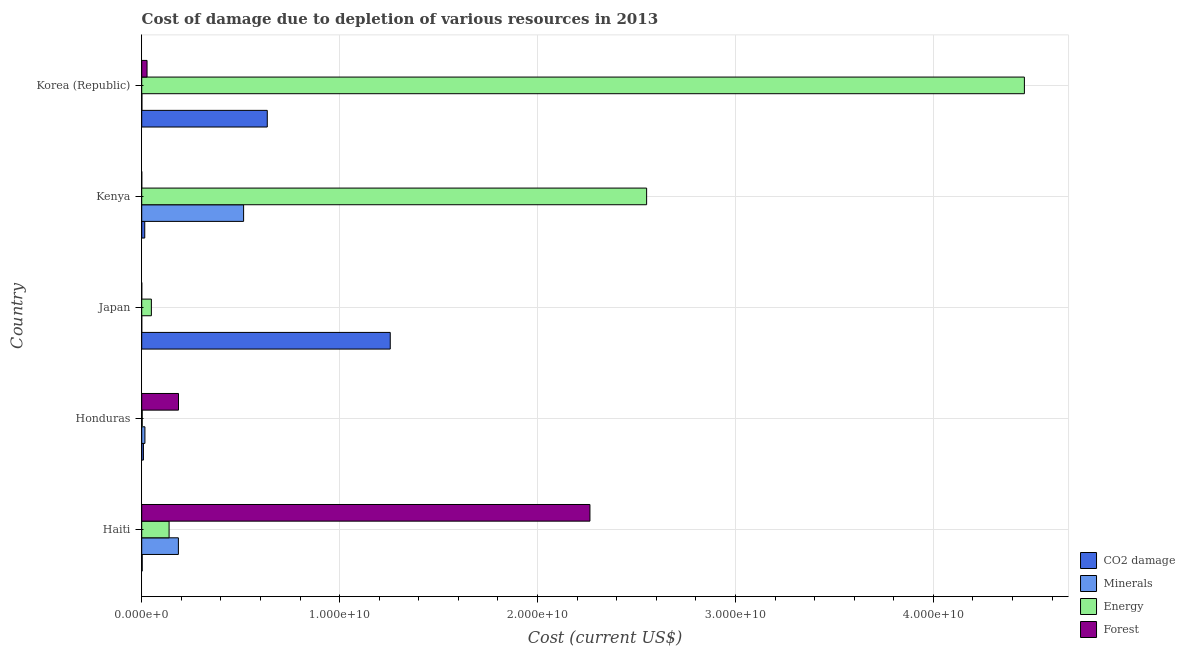How many different coloured bars are there?
Keep it short and to the point. 4. How many bars are there on the 5th tick from the bottom?
Give a very brief answer. 4. What is the cost of damage due to depletion of minerals in Honduras?
Offer a terse response. 1.62e+08. Across all countries, what is the maximum cost of damage due to depletion of forests?
Keep it short and to the point. 2.26e+1. Across all countries, what is the minimum cost of damage due to depletion of coal?
Your answer should be compact. 2.43e+07. In which country was the cost of damage due to depletion of forests maximum?
Your answer should be compact. Haiti. In which country was the cost of damage due to depletion of energy minimum?
Offer a very short reply. Honduras. What is the total cost of damage due to depletion of coal in the graph?
Offer a terse response. 1.92e+1. What is the difference between the cost of damage due to depletion of forests in Japan and that in Kenya?
Provide a succinct answer. -1.29e+06. What is the difference between the cost of damage due to depletion of minerals in Japan and the cost of damage due to depletion of coal in Honduras?
Keep it short and to the point. -8.53e+07. What is the average cost of damage due to depletion of coal per country?
Give a very brief answer. 3.83e+09. What is the difference between the cost of damage due to depletion of coal and cost of damage due to depletion of minerals in Haiti?
Your response must be concise. -1.83e+09. What is the ratio of the cost of damage due to depletion of energy in Kenya to that in Korea (Republic)?
Provide a short and direct response. 0.57. Is the difference between the cost of damage due to depletion of minerals in Kenya and Korea (Republic) greater than the difference between the cost of damage due to depletion of coal in Kenya and Korea (Republic)?
Ensure brevity in your answer.  Yes. What is the difference between the highest and the second highest cost of damage due to depletion of forests?
Make the answer very short. 2.08e+1. What is the difference between the highest and the lowest cost of damage due to depletion of minerals?
Give a very brief answer. 5.15e+09. Is it the case that in every country, the sum of the cost of damage due to depletion of minerals and cost of damage due to depletion of forests is greater than the sum of cost of damage due to depletion of energy and cost of damage due to depletion of coal?
Offer a terse response. No. What does the 2nd bar from the top in Haiti represents?
Your answer should be compact. Energy. What does the 2nd bar from the bottom in Haiti represents?
Your answer should be very brief. Minerals. How many bars are there?
Ensure brevity in your answer.  20. How many countries are there in the graph?
Your response must be concise. 5. What is the difference between two consecutive major ticks on the X-axis?
Offer a terse response. 1.00e+1. Does the graph contain grids?
Provide a succinct answer. Yes. How many legend labels are there?
Your response must be concise. 4. How are the legend labels stacked?
Offer a very short reply. Vertical. What is the title of the graph?
Offer a very short reply. Cost of damage due to depletion of various resources in 2013 . Does "Norway" appear as one of the legend labels in the graph?
Give a very brief answer. No. What is the label or title of the X-axis?
Give a very brief answer. Cost (current US$). What is the label or title of the Y-axis?
Your answer should be compact. Country. What is the Cost (current US$) in CO2 damage in Haiti?
Keep it short and to the point. 2.43e+07. What is the Cost (current US$) in Minerals in Haiti?
Offer a very short reply. 1.85e+09. What is the Cost (current US$) in Energy in Haiti?
Your response must be concise. 1.38e+09. What is the Cost (current US$) of Forest in Haiti?
Keep it short and to the point. 2.26e+1. What is the Cost (current US$) in CO2 damage in Honduras?
Keep it short and to the point. 8.56e+07. What is the Cost (current US$) in Minerals in Honduras?
Your answer should be very brief. 1.62e+08. What is the Cost (current US$) in Energy in Honduras?
Ensure brevity in your answer.  2.46e+07. What is the Cost (current US$) of Forest in Honduras?
Your response must be concise. 1.86e+09. What is the Cost (current US$) of CO2 damage in Japan?
Your response must be concise. 1.26e+1. What is the Cost (current US$) of Minerals in Japan?
Your answer should be compact. 3.10e+05. What is the Cost (current US$) of Energy in Japan?
Ensure brevity in your answer.  4.87e+08. What is the Cost (current US$) of Forest in Japan?
Your response must be concise. 2.51e+05. What is the Cost (current US$) in CO2 damage in Kenya?
Keep it short and to the point. 1.53e+08. What is the Cost (current US$) in Minerals in Kenya?
Offer a very short reply. 5.15e+09. What is the Cost (current US$) in Energy in Kenya?
Your response must be concise. 2.55e+1. What is the Cost (current US$) of Forest in Kenya?
Your answer should be compact. 1.54e+06. What is the Cost (current US$) in CO2 damage in Korea (Republic)?
Give a very brief answer. 6.34e+09. What is the Cost (current US$) of Minerals in Korea (Republic)?
Make the answer very short. 8.60e+06. What is the Cost (current US$) in Energy in Korea (Republic)?
Offer a terse response. 4.46e+1. What is the Cost (current US$) of Forest in Korea (Republic)?
Offer a terse response. 2.69e+08. Across all countries, what is the maximum Cost (current US$) of CO2 damage?
Offer a very short reply. 1.26e+1. Across all countries, what is the maximum Cost (current US$) of Minerals?
Your answer should be compact. 5.15e+09. Across all countries, what is the maximum Cost (current US$) in Energy?
Provide a short and direct response. 4.46e+1. Across all countries, what is the maximum Cost (current US$) of Forest?
Provide a short and direct response. 2.26e+1. Across all countries, what is the minimum Cost (current US$) of CO2 damage?
Your answer should be compact. 2.43e+07. Across all countries, what is the minimum Cost (current US$) of Minerals?
Ensure brevity in your answer.  3.10e+05. Across all countries, what is the minimum Cost (current US$) of Energy?
Your answer should be very brief. 2.46e+07. Across all countries, what is the minimum Cost (current US$) in Forest?
Provide a succinct answer. 2.51e+05. What is the total Cost (current US$) in CO2 damage in the graph?
Your response must be concise. 1.92e+1. What is the total Cost (current US$) of Minerals in the graph?
Provide a succinct answer. 7.17e+09. What is the total Cost (current US$) of Energy in the graph?
Your answer should be very brief. 7.20e+1. What is the total Cost (current US$) in Forest in the graph?
Provide a succinct answer. 2.48e+1. What is the difference between the Cost (current US$) of CO2 damage in Haiti and that in Honduras?
Your answer should be very brief. -6.14e+07. What is the difference between the Cost (current US$) of Minerals in Haiti and that in Honduras?
Offer a very short reply. 1.69e+09. What is the difference between the Cost (current US$) of Energy in Haiti and that in Honduras?
Your answer should be compact. 1.36e+09. What is the difference between the Cost (current US$) of Forest in Haiti and that in Honduras?
Your response must be concise. 2.08e+1. What is the difference between the Cost (current US$) of CO2 damage in Haiti and that in Japan?
Offer a terse response. -1.25e+1. What is the difference between the Cost (current US$) in Minerals in Haiti and that in Japan?
Your answer should be compact. 1.85e+09. What is the difference between the Cost (current US$) of Energy in Haiti and that in Japan?
Provide a succinct answer. 8.95e+08. What is the difference between the Cost (current US$) of Forest in Haiti and that in Japan?
Give a very brief answer. 2.26e+1. What is the difference between the Cost (current US$) of CO2 damage in Haiti and that in Kenya?
Ensure brevity in your answer.  -1.29e+08. What is the difference between the Cost (current US$) of Minerals in Haiti and that in Kenya?
Your response must be concise. -3.30e+09. What is the difference between the Cost (current US$) in Energy in Haiti and that in Kenya?
Offer a terse response. -2.41e+1. What is the difference between the Cost (current US$) of Forest in Haiti and that in Kenya?
Give a very brief answer. 2.26e+1. What is the difference between the Cost (current US$) in CO2 damage in Haiti and that in Korea (Republic)?
Offer a very short reply. -6.32e+09. What is the difference between the Cost (current US$) in Minerals in Haiti and that in Korea (Republic)?
Keep it short and to the point. 1.84e+09. What is the difference between the Cost (current US$) in Energy in Haiti and that in Korea (Republic)?
Keep it short and to the point. -4.32e+1. What is the difference between the Cost (current US$) in Forest in Haiti and that in Korea (Republic)?
Your answer should be very brief. 2.24e+1. What is the difference between the Cost (current US$) in CO2 damage in Honduras and that in Japan?
Keep it short and to the point. -1.25e+1. What is the difference between the Cost (current US$) in Minerals in Honduras and that in Japan?
Your answer should be compact. 1.62e+08. What is the difference between the Cost (current US$) in Energy in Honduras and that in Japan?
Make the answer very short. -4.63e+08. What is the difference between the Cost (current US$) in Forest in Honduras and that in Japan?
Your answer should be compact. 1.86e+09. What is the difference between the Cost (current US$) in CO2 damage in Honduras and that in Kenya?
Make the answer very short. -6.77e+07. What is the difference between the Cost (current US$) in Minerals in Honduras and that in Kenya?
Your response must be concise. -4.99e+09. What is the difference between the Cost (current US$) of Energy in Honduras and that in Kenya?
Your answer should be very brief. -2.55e+1. What is the difference between the Cost (current US$) in Forest in Honduras and that in Kenya?
Your answer should be compact. 1.86e+09. What is the difference between the Cost (current US$) in CO2 damage in Honduras and that in Korea (Republic)?
Make the answer very short. -6.26e+09. What is the difference between the Cost (current US$) of Minerals in Honduras and that in Korea (Republic)?
Offer a terse response. 1.53e+08. What is the difference between the Cost (current US$) in Energy in Honduras and that in Korea (Republic)?
Make the answer very short. -4.46e+1. What is the difference between the Cost (current US$) in Forest in Honduras and that in Korea (Republic)?
Give a very brief answer. 1.59e+09. What is the difference between the Cost (current US$) of CO2 damage in Japan and that in Kenya?
Your answer should be very brief. 1.24e+1. What is the difference between the Cost (current US$) in Minerals in Japan and that in Kenya?
Keep it short and to the point. -5.15e+09. What is the difference between the Cost (current US$) of Energy in Japan and that in Kenya?
Provide a succinct answer. -2.50e+1. What is the difference between the Cost (current US$) of Forest in Japan and that in Kenya?
Offer a very short reply. -1.29e+06. What is the difference between the Cost (current US$) of CO2 damage in Japan and that in Korea (Republic)?
Your response must be concise. 6.21e+09. What is the difference between the Cost (current US$) of Minerals in Japan and that in Korea (Republic)?
Ensure brevity in your answer.  -8.29e+06. What is the difference between the Cost (current US$) in Energy in Japan and that in Korea (Republic)?
Offer a very short reply. -4.41e+1. What is the difference between the Cost (current US$) in Forest in Japan and that in Korea (Republic)?
Provide a succinct answer. -2.69e+08. What is the difference between the Cost (current US$) in CO2 damage in Kenya and that in Korea (Republic)?
Offer a very short reply. -6.19e+09. What is the difference between the Cost (current US$) in Minerals in Kenya and that in Korea (Republic)?
Provide a succinct answer. 5.14e+09. What is the difference between the Cost (current US$) of Energy in Kenya and that in Korea (Republic)?
Offer a terse response. -1.91e+1. What is the difference between the Cost (current US$) of Forest in Kenya and that in Korea (Republic)?
Make the answer very short. -2.68e+08. What is the difference between the Cost (current US$) of CO2 damage in Haiti and the Cost (current US$) of Minerals in Honduras?
Offer a very short reply. -1.38e+08. What is the difference between the Cost (current US$) of CO2 damage in Haiti and the Cost (current US$) of Energy in Honduras?
Keep it short and to the point. -3.39e+05. What is the difference between the Cost (current US$) in CO2 damage in Haiti and the Cost (current US$) in Forest in Honduras?
Offer a terse response. -1.83e+09. What is the difference between the Cost (current US$) in Minerals in Haiti and the Cost (current US$) in Energy in Honduras?
Provide a short and direct response. 1.83e+09. What is the difference between the Cost (current US$) in Minerals in Haiti and the Cost (current US$) in Forest in Honduras?
Offer a terse response. -5.24e+06. What is the difference between the Cost (current US$) of Energy in Haiti and the Cost (current US$) of Forest in Honduras?
Your response must be concise. -4.76e+08. What is the difference between the Cost (current US$) in CO2 damage in Haiti and the Cost (current US$) in Minerals in Japan?
Provide a succinct answer. 2.39e+07. What is the difference between the Cost (current US$) in CO2 damage in Haiti and the Cost (current US$) in Energy in Japan?
Offer a terse response. -4.63e+08. What is the difference between the Cost (current US$) in CO2 damage in Haiti and the Cost (current US$) in Forest in Japan?
Your response must be concise. 2.40e+07. What is the difference between the Cost (current US$) in Minerals in Haiti and the Cost (current US$) in Energy in Japan?
Your answer should be compact. 1.37e+09. What is the difference between the Cost (current US$) in Minerals in Haiti and the Cost (current US$) in Forest in Japan?
Provide a succinct answer. 1.85e+09. What is the difference between the Cost (current US$) in Energy in Haiti and the Cost (current US$) in Forest in Japan?
Your response must be concise. 1.38e+09. What is the difference between the Cost (current US$) in CO2 damage in Haiti and the Cost (current US$) in Minerals in Kenya?
Your answer should be very brief. -5.12e+09. What is the difference between the Cost (current US$) in CO2 damage in Haiti and the Cost (current US$) in Energy in Kenya?
Offer a terse response. -2.55e+1. What is the difference between the Cost (current US$) of CO2 damage in Haiti and the Cost (current US$) of Forest in Kenya?
Your response must be concise. 2.27e+07. What is the difference between the Cost (current US$) in Minerals in Haiti and the Cost (current US$) in Energy in Kenya?
Your response must be concise. -2.37e+1. What is the difference between the Cost (current US$) of Minerals in Haiti and the Cost (current US$) of Forest in Kenya?
Ensure brevity in your answer.  1.85e+09. What is the difference between the Cost (current US$) of Energy in Haiti and the Cost (current US$) of Forest in Kenya?
Offer a very short reply. 1.38e+09. What is the difference between the Cost (current US$) of CO2 damage in Haiti and the Cost (current US$) of Minerals in Korea (Republic)?
Provide a short and direct response. 1.56e+07. What is the difference between the Cost (current US$) of CO2 damage in Haiti and the Cost (current US$) of Energy in Korea (Republic)?
Provide a succinct answer. -4.46e+1. What is the difference between the Cost (current US$) in CO2 damage in Haiti and the Cost (current US$) in Forest in Korea (Republic)?
Offer a very short reply. -2.45e+08. What is the difference between the Cost (current US$) in Minerals in Haiti and the Cost (current US$) in Energy in Korea (Republic)?
Ensure brevity in your answer.  -4.27e+1. What is the difference between the Cost (current US$) in Minerals in Haiti and the Cost (current US$) in Forest in Korea (Republic)?
Make the answer very short. 1.58e+09. What is the difference between the Cost (current US$) in Energy in Haiti and the Cost (current US$) in Forest in Korea (Republic)?
Offer a very short reply. 1.11e+09. What is the difference between the Cost (current US$) of CO2 damage in Honduras and the Cost (current US$) of Minerals in Japan?
Provide a succinct answer. 8.53e+07. What is the difference between the Cost (current US$) in CO2 damage in Honduras and the Cost (current US$) in Energy in Japan?
Ensure brevity in your answer.  -4.02e+08. What is the difference between the Cost (current US$) of CO2 damage in Honduras and the Cost (current US$) of Forest in Japan?
Your answer should be compact. 8.54e+07. What is the difference between the Cost (current US$) of Minerals in Honduras and the Cost (current US$) of Energy in Japan?
Your response must be concise. -3.26e+08. What is the difference between the Cost (current US$) of Minerals in Honduras and the Cost (current US$) of Forest in Japan?
Offer a very short reply. 1.62e+08. What is the difference between the Cost (current US$) in Energy in Honduras and the Cost (current US$) in Forest in Japan?
Your answer should be very brief. 2.43e+07. What is the difference between the Cost (current US$) of CO2 damage in Honduras and the Cost (current US$) of Minerals in Kenya?
Provide a short and direct response. -5.06e+09. What is the difference between the Cost (current US$) in CO2 damage in Honduras and the Cost (current US$) in Energy in Kenya?
Make the answer very short. -2.54e+1. What is the difference between the Cost (current US$) of CO2 damage in Honduras and the Cost (current US$) of Forest in Kenya?
Keep it short and to the point. 8.41e+07. What is the difference between the Cost (current US$) of Minerals in Honduras and the Cost (current US$) of Energy in Kenya?
Your answer should be compact. -2.53e+1. What is the difference between the Cost (current US$) in Minerals in Honduras and the Cost (current US$) in Forest in Kenya?
Your response must be concise. 1.60e+08. What is the difference between the Cost (current US$) in Energy in Honduras and the Cost (current US$) in Forest in Kenya?
Your answer should be compact. 2.30e+07. What is the difference between the Cost (current US$) of CO2 damage in Honduras and the Cost (current US$) of Minerals in Korea (Republic)?
Keep it short and to the point. 7.70e+07. What is the difference between the Cost (current US$) of CO2 damage in Honduras and the Cost (current US$) of Energy in Korea (Republic)?
Give a very brief answer. -4.45e+1. What is the difference between the Cost (current US$) of CO2 damage in Honduras and the Cost (current US$) of Forest in Korea (Republic)?
Your response must be concise. -1.84e+08. What is the difference between the Cost (current US$) in Minerals in Honduras and the Cost (current US$) in Energy in Korea (Republic)?
Your answer should be very brief. -4.44e+1. What is the difference between the Cost (current US$) in Minerals in Honduras and the Cost (current US$) in Forest in Korea (Republic)?
Provide a succinct answer. -1.07e+08. What is the difference between the Cost (current US$) in Energy in Honduras and the Cost (current US$) in Forest in Korea (Republic)?
Give a very brief answer. -2.45e+08. What is the difference between the Cost (current US$) of CO2 damage in Japan and the Cost (current US$) of Minerals in Kenya?
Your answer should be very brief. 7.41e+09. What is the difference between the Cost (current US$) of CO2 damage in Japan and the Cost (current US$) of Energy in Kenya?
Your answer should be very brief. -1.30e+1. What is the difference between the Cost (current US$) of CO2 damage in Japan and the Cost (current US$) of Forest in Kenya?
Give a very brief answer. 1.26e+1. What is the difference between the Cost (current US$) of Minerals in Japan and the Cost (current US$) of Energy in Kenya?
Provide a short and direct response. -2.55e+1. What is the difference between the Cost (current US$) in Minerals in Japan and the Cost (current US$) in Forest in Kenya?
Your answer should be very brief. -1.23e+06. What is the difference between the Cost (current US$) of Energy in Japan and the Cost (current US$) of Forest in Kenya?
Make the answer very short. 4.86e+08. What is the difference between the Cost (current US$) of CO2 damage in Japan and the Cost (current US$) of Minerals in Korea (Republic)?
Make the answer very short. 1.25e+1. What is the difference between the Cost (current US$) of CO2 damage in Japan and the Cost (current US$) of Energy in Korea (Republic)?
Your response must be concise. -3.20e+1. What is the difference between the Cost (current US$) in CO2 damage in Japan and the Cost (current US$) in Forest in Korea (Republic)?
Give a very brief answer. 1.23e+1. What is the difference between the Cost (current US$) of Minerals in Japan and the Cost (current US$) of Energy in Korea (Republic)?
Offer a very short reply. -4.46e+1. What is the difference between the Cost (current US$) of Minerals in Japan and the Cost (current US$) of Forest in Korea (Republic)?
Offer a terse response. -2.69e+08. What is the difference between the Cost (current US$) of Energy in Japan and the Cost (current US$) of Forest in Korea (Republic)?
Ensure brevity in your answer.  2.18e+08. What is the difference between the Cost (current US$) in CO2 damage in Kenya and the Cost (current US$) in Minerals in Korea (Republic)?
Offer a terse response. 1.45e+08. What is the difference between the Cost (current US$) in CO2 damage in Kenya and the Cost (current US$) in Energy in Korea (Republic)?
Offer a terse response. -4.44e+1. What is the difference between the Cost (current US$) in CO2 damage in Kenya and the Cost (current US$) in Forest in Korea (Republic)?
Provide a short and direct response. -1.16e+08. What is the difference between the Cost (current US$) of Minerals in Kenya and the Cost (current US$) of Energy in Korea (Republic)?
Offer a terse response. -3.94e+1. What is the difference between the Cost (current US$) in Minerals in Kenya and the Cost (current US$) in Forest in Korea (Republic)?
Your answer should be very brief. 4.88e+09. What is the difference between the Cost (current US$) in Energy in Kenya and the Cost (current US$) in Forest in Korea (Republic)?
Give a very brief answer. 2.52e+1. What is the average Cost (current US$) in CO2 damage per country?
Ensure brevity in your answer.  3.83e+09. What is the average Cost (current US$) of Minerals per country?
Keep it short and to the point. 1.43e+09. What is the average Cost (current US$) of Energy per country?
Provide a short and direct response. 1.44e+1. What is the average Cost (current US$) in Forest per country?
Provide a short and direct response. 4.96e+09. What is the difference between the Cost (current US$) of CO2 damage and Cost (current US$) of Minerals in Haiti?
Your answer should be compact. -1.83e+09. What is the difference between the Cost (current US$) of CO2 damage and Cost (current US$) of Energy in Haiti?
Provide a short and direct response. -1.36e+09. What is the difference between the Cost (current US$) of CO2 damage and Cost (current US$) of Forest in Haiti?
Provide a succinct answer. -2.26e+1. What is the difference between the Cost (current US$) of Minerals and Cost (current US$) of Energy in Haiti?
Keep it short and to the point. 4.70e+08. What is the difference between the Cost (current US$) of Minerals and Cost (current US$) of Forest in Haiti?
Make the answer very short. -2.08e+1. What is the difference between the Cost (current US$) in Energy and Cost (current US$) in Forest in Haiti?
Keep it short and to the point. -2.13e+1. What is the difference between the Cost (current US$) in CO2 damage and Cost (current US$) in Minerals in Honduras?
Your response must be concise. -7.63e+07. What is the difference between the Cost (current US$) of CO2 damage and Cost (current US$) of Energy in Honduras?
Keep it short and to the point. 6.10e+07. What is the difference between the Cost (current US$) of CO2 damage and Cost (current US$) of Forest in Honduras?
Give a very brief answer. -1.77e+09. What is the difference between the Cost (current US$) in Minerals and Cost (current US$) in Energy in Honduras?
Your answer should be very brief. 1.37e+08. What is the difference between the Cost (current US$) in Minerals and Cost (current US$) in Forest in Honduras?
Offer a terse response. -1.70e+09. What is the difference between the Cost (current US$) of Energy and Cost (current US$) of Forest in Honduras?
Your answer should be compact. -1.83e+09. What is the difference between the Cost (current US$) of CO2 damage and Cost (current US$) of Minerals in Japan?
Keep it short and to the point. 1.26e+1. What is the difference between the Cost (current US$) of CO2 damage and Cost (current US$) of Energy in Japan?
Offer a terse response. 1.21e+1. What is the difference between the Cost (current US$) in CO2 damage and Cost (current US$) in Forest in Japan?
Provide a succinct answer. 1.26e+1. What is the difference between the Cost (current US$) of Minerals and Cost (current US$) of Energy in Japan?
Ensure brevity in your answer.  -4.87e+08. What is the difference between the Cost (current US$) in Minerals and Cost (current US$) in Forest in Japan?
Keep it short and to the point. 5.93e+04. What is the difference between the Cost (current US$) of Energy and Cost (current US$) of Forest in Japan?
Give a very brief answer. 4.87e+08. What is the difference between the Cost (current US$) of CO2 damage and Cost (current US$) of Minerals in Kenya?
Provide a short and direct response. -5.00e+09. What is the difference between the Cost (current US$) in CO2 damage and Cost (current US$) in Energy in Kenya?
Keep it short and to the point. -2.54e+1. What is the difference between the Cost (current US$) of CO2 damage and Cost (current US$) of Forest in Kenya?
Your answer should be compact. 1.52e+08. What is the difference between the Cost (current US$) of Minerals and Cost (current US$) of Energy in Kenya?
Make the answer very short. -2.04e+1. What is the difference between the Cost (current US$) in Minerals and Cost (current US$) in Forest in Kenya?
Ensure brevity in your answer.  5.15e+09. What is the difference between the Cost (current US$) of Energy and Cost (current US$) of Forest in Kenya?
Offer a terse response. 2.55e+1. What is the difference between the Cost (current US$) in CO2 damage and Cost (current US$) in Minerals in Korea (Republic)?
Offer a terse response. 6.34e+09. What is the difference between the Cost (current US$) in CO2 damage and Cost (current US$) in Energy in Korea (Republic)?
Ensure brevity in your answer.  -3.83e+1. What is the difference between the Cost (current US$) in CO2 damage and Cost (current US$) in Forest in Korea (Republic)?
Provide a succinct answer. 6.07e+09. What is the difference between the Cost (current US$) of Minerals and Cost (current US$) of Energy in Korea (Republic)?
Ensure brevity in your answer.  -4.46e+1. What is the difference between the Cost (current US$) in Minerals and Cost (current US$) in Forest in Korea (Republic)?
Make the answer very short. -2.61e+08. What is the difference between the Cost (current US$) of Energy and Cost (current US$) of Forest in Korea (Republic)?
Ensure brevity in your answer.  4.43e+1. What is the ratio of the Cost (current US$) in CO2 damage in Haiti to that in Honduras?
Provide a short and direct response. 0.28. What is the ratio of the Cost (current US$) of Minerals in Haiti to that in Honduras?
Provide a short and direct response. 11.45. What is the ratio of the Cost (current US$) in Energy in Haiti to that in Honduras?
Your response must be concise. 56.23. What is the ratio of the Cost (current US$) of Forest in Haiti to that in Honduras?
Your answer should be compact. 12.19. What is the ratio of the Cost (current US$) in CO2 damage in Haiti to that in Japan?
Your answer should be compact. 0. What is the ratio of the Cost (current US$) in Minerals in Haiti to that in Japan?
Make the answer very short. 5978.24. What is the ratio of the Cost (current US$) of Energy in Haiti to that in Japan?
Make the answer very short. 2.84. What is the ratio of the Cost (current US$) of Forest in Haiti to that in Japan?
Your answer should be compact. 9.03e+04. What is the ratio of the Cost (current US$) in CO2 damage in Haiti to that in Kenya?
Make the answer very short. 0.16. What is the ratio of the Cost (current US$) of Minerals in Haiti to that in Kenya?
Your answer should be compact. 0.36. What is the ratio of the Cost (current US$) in Energy in Haiti to that in Kenya?
Your answer should be very brief. 0.05. What is the ratio of the Cost (current US$) in Forest in Haiti to that in Kenya?
Your answer should be very brief. 1.47e+04. What is the ratio of the Cost (current US$) in CO2 damage in Haiti to that in Korea (Republic)?
Provide a succinct answer. 0. What is the ratio of the Cost (current US$) in Minerals in Haiti to that in Korea (Republic)?
Your response must be concise. 215.42. What is the ratio of the Cost (current US$) of Energy in Haiti to that in Korea (Republic)?
Give a very brief answer. 0.03. What is the ratio of the Cost (current US$) of Forest in Haiti to that in Korea (Republic)?
Make the answer very short. 84.1. What is the ratio of the Cost (current US$) of CO2 damage in Honduras to that in Japan?
Offer a very short reply. 0.01. What is the ratio of the Cost (current US$) in Minerals in Honduras to that in Japan?
Offer a very short reply. 522.25. What is the ratio of the Cost (current US$) in Energy in Honduras to that in Japan?
Your response must be concise. 0.05. What is the ratio of the Cost (current US$) of Forest in Honduras to that in Japan?
Offer a terse response. 7413.82. What is the ratio of the Cost (current US$) in CO2 damage in Honduras to that in Kenya?
Provide a succinct answer. 0.56. What is the ratio of the Cost (current US$) in Minerals in Honduras to that in Kenya?
Provide a succinct answer. 0.03. What is the ratio of the Cost (current US$) of Forest in Honduras to that in Kenya?
Your answer should be very brief. 1204.94. What is the ratio of the Cost (current US$) in CO2 damage in Honduras to that in Korea (Republic)?
Give a very brief answer. 0.01. What is the ratio of the Cost (current US$) in Minerals in Honduras to that in Korea (Republic)?
Provide a succinct answer. 18.82. What is the ratio of the Cost (current US$) of Energy in Honduras to that in Korea (Republic)?
Provide a succinct answer. 0. What is the ratio of the Cost (current US$) of Forest in Honduras to that in Korea (Republic)?
Keep it short and to the point. 6.9. What is the ratio of the Cost (current US$) of CO2 damage in Japan to that in Kenya?
Provide a short and direct response. 81.91. What is the ratio of the Cost (current US$) in Minerals in Japan to that in Kenya?
Keep it short and to the point. 0. What is the ratio of the Cost (current US$) in Energy in Japan to that in Kenya?
Offer a very short reply. 0.02. What is the ratio of the Cost (current US$) in Forest in Japan to that in Kenya?
Give a very brief answer. 0.16. What is the ratio of the Cost (current US$) of CO2 damage in Japan to that in Korea (Republic)?
Your answer should be compact. 1.98. What is the ratio of the Cost (current US$) of Minerals in Japan to that in Korea (Republic)?
Your answer should be very brief. 0.04. What is the ratio of the Cost (current US$) of Energy in Japan to that in Korea (Republic)?
Give a very brief answer. 0.01. What is the ratio of the Cost (current US$) in Forest in Japan to that in Korea (Republic)?
Offer a very short reply. 0. What is the ratio of the Cost (current US$) of CO2 damage in Kenya to that in Korea (Republic)?
Your answer should be very brief. 0.02. What is the ratio of the Cost (current US$) in Minerals in Kenya to that in Korea (Republic)?
Your response must be concise. 598.5. What is the ratio of the Cost (current US$) in Energy in Kenya to that in Korea (Republic)?
Offer a very short reply. 0.57. What is the ratio of the Cost (current US$) in Forest in Kenya to that in Korea (Republic)?
Make the answer very short. 0.01. What is the difference between the highest and the second highest Cost (current US$) in CO2 damage?
Your answer should be compact. 6.21e+09. What is the difference between the highest and the second highest Cost (current US$) of Minerals?
Offer a terse response. 3.30e+09. What is the difference between the highest and the second highest Cost (current US$) of Energy?
Offer a very short reply. 1.91e+1. What is the difference between the highest and the second highest Cost (current US$) of Forest?
Your answer should be compact. 2.08e+1. What is the difference between the highest and the lowest Cost (current US$) of CO2 damage?
Your response must be concise. 1.25e+1. What is the difference between the highest and the lowest Cost (current US$) in Minerals?
Make the answer very short. 5.15e+09. What is the difference between the highest and the lowest Cost (current US$) in Energy?
Your response must be concise. 4.46e+1. What is the difference between the highest and the lowest Cost (current US$) in Forest?
Provide a short and direct response. 2.26e+1. 